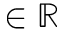<formula> <loc_0><loc_0><loc_500><loc_500>\in \mathbb { R }</formula> 